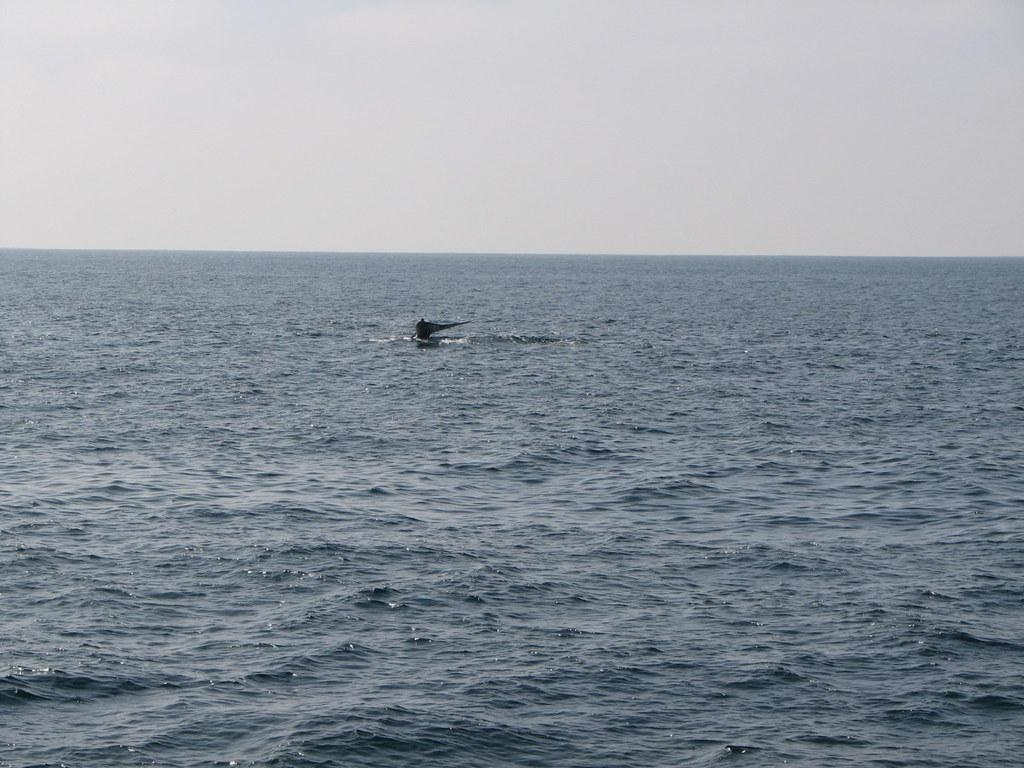What is the main subject of the image? There is a black object in the image. Where is the black object located? The black object is on the water. What can be seen in the background of the image? The sky is visible in the background of the image. What type of honey is being harvested from the black object in the image? There is no honey or honey harvesting activity present in the image. The image only features a black object on the water with the sky visible in the background. 